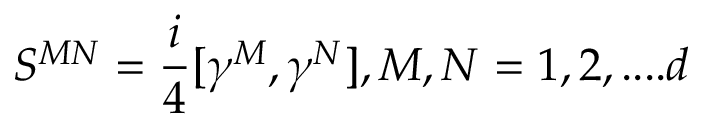<formula> <loc_0><loc_0><loc_500><loc_500>S ^ { M N } = { \frac { i } { 4 } } [ \gamma ^ { M } , \gamma ^ { N } ] , M , N = 1 , 2 , \cdots d</formula> 